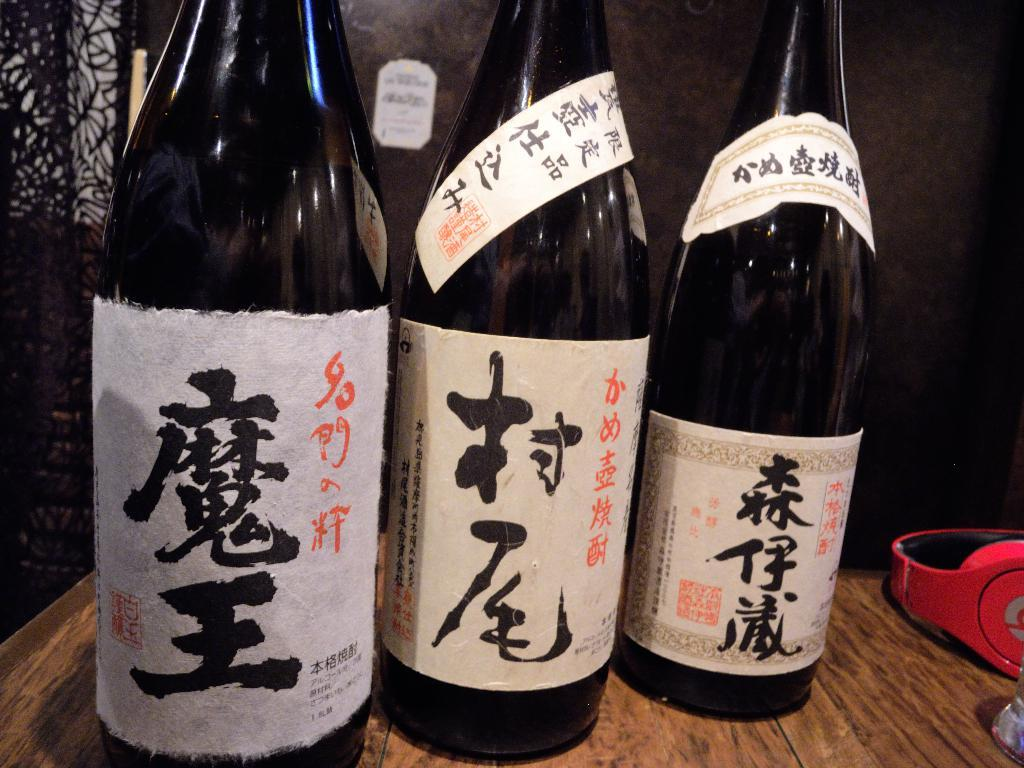What is located at the bottom of the image? There is a table at the bottom of the image. What objects are on the table? There are bottles and a headphone on the table. What can be seen behind the table? There is a wall visible behind the table. What type of treatment is being administered to the orange in the image? There is no orange present in the image, so no treatment can be administered to it. 